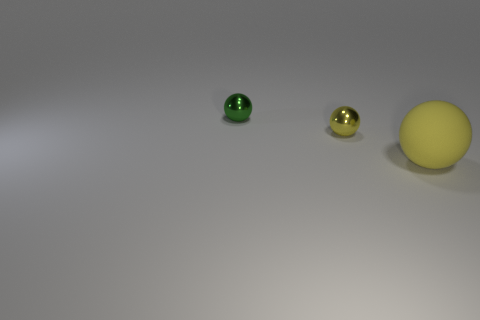Add 3 small balls. How many objects exist? 6 Subtract 0 purple spheres. How many objects are left? 3 Subtract all large yellow balls. Subtract all rubber spheres. How many objects are left? 1 Add 3 large yellow balls. How many large yellow balls are left? 4 Add 1 yellow rubber objects. How many yellow rubber objects exist? 2 